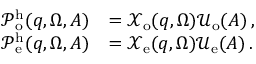Convert formula to latex. <formula><loc_0><loc_0><loc_500><loc_500>\begin{array} { r l } { \mathcal { P } _ { o } ^ { h } ( q , \Omega , A ) } & { = \mathcal { X } _ { o } ( q , \Omega ) \mathcal { U } _ { o } ( A ) \, , } \\ { \mathcal { P } _ { e } ^ { h } ( q , \Omega , A ) } & { = \mathcal { X } _ { e } ( q , \Omega ) \mathcal { U } _ { e } ( A ) \, . } \end{array}</formula> 